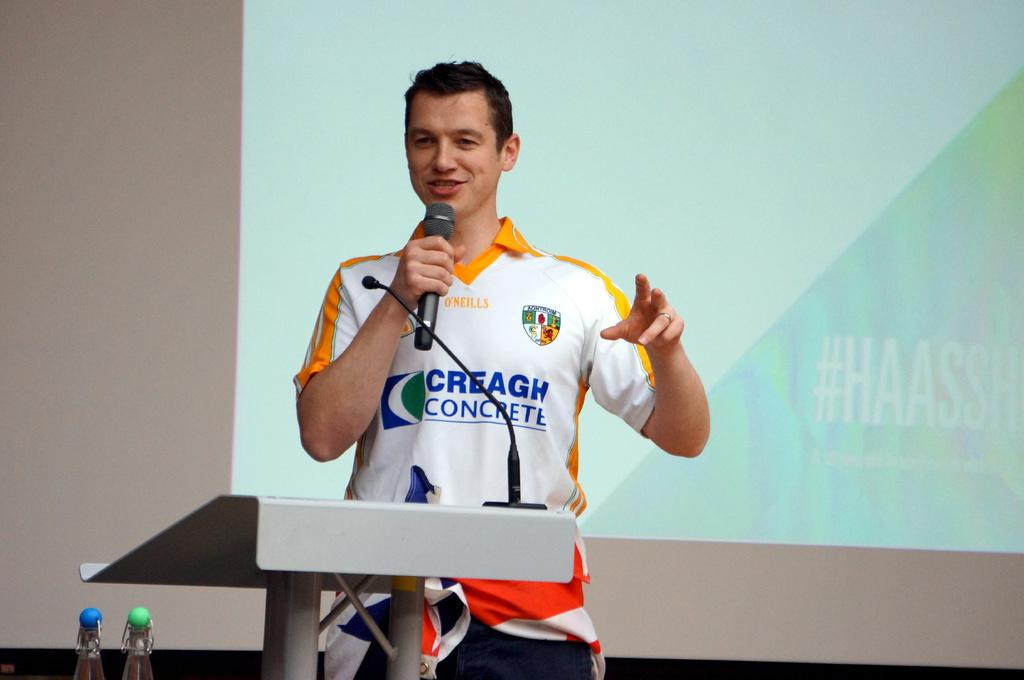<image>
Write a terse but informative summary of the picture. A man talking on a microphone has a shirt on with CONCRETE printed on the front of it. 